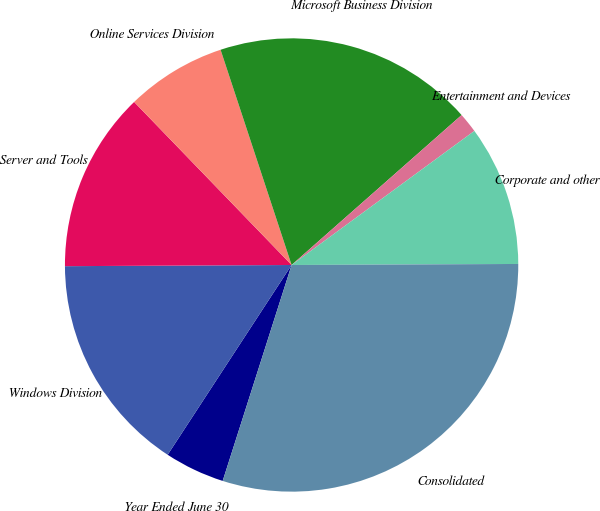Convert chart to OTSL. <chart><loc_0><loc_0><loc_500><loc_500><pie_chart><fcel>Year Ended June 30<fcel>Windows Division<fcel>Server and Tools<fcel>Online Services Division<fcel>Microsoft Business Division<fcel>Entertainment and Devices<fcel>Corporate and other<fcel>Consolidated<nl><fcel>4.29%<fcel>15.71%<fcel>12.86%<fcel>7.15%<fcel>18.57%<fcel>1.43%<fcel>10.0%<fcel>29.99%<nl></chart> 